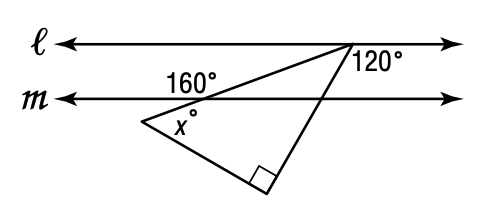Answer the mathemtical geometry problem and directly provide the correct option letter.
Question: Line l is parallel to line m. What is the value of x?
Choices: A: 30 B: 40 C: 50 D: 60 C 